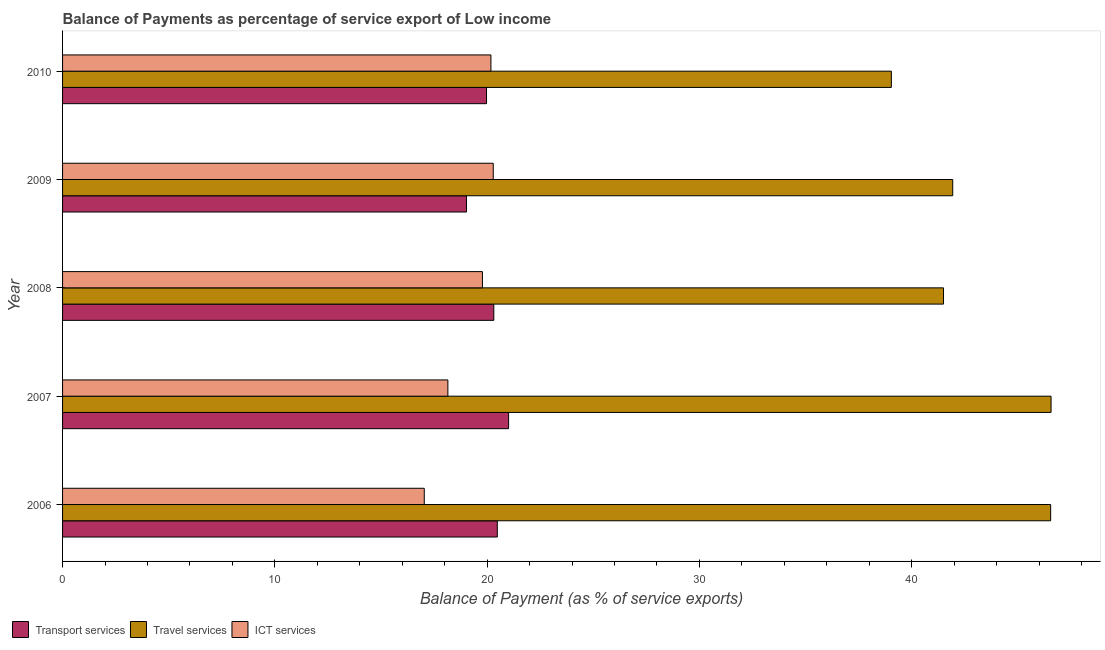How many different coloured bars are there?
Make the answer very short. 3. Are the number of bars per tick equal to the number of legend labels?
Provide a succinct answer. Yes. Are the number of bars on each tick of the Y-axis equal?
Keep it short and to the point. Yes. How many bars are there on the 4th tick from the top?
Your answer should be very brief. 3. In how many cases, is the number of bars for a given year not equal to the number of legend labels?
Make the answer very short. 0. What is the balance of payment of ict services in 2008?
Keep it short and to the point. 19.78. Across all years, what is the maximum balance of payment of ict services?
Provide a succinct answer. 20.29. Across all years, what is the minimum balance of payment of transport services?
Provide a short and direct response. 19.03. In which year was the balance of payment of transport services maximum?
Your response must be concise. 2007. What is the total balance of payment of ict services in the graph?
Make the answer very short. 95.43. What is the difference between the balance of payment of ict services in 2008 and that in 2010?
Provide a succinct answer. -0.4. What is the difference between the balance of payment of ict services in 2010 and the balance of payment of travel services in 2009?
Keep it short and to the point. -21.75. What is the average balance of payment of transport services per year?
Offer a terse response. 20.16. In the year 2006, what is the difference between the balance of payment of transport services and balance of payment of travel services?
Offer a terse response. -26.07. What is the ratio of the balance of payment of transport services in 2007 to that in 2009?
Make the answer very short. 1.1. Is the balance of payment of ict services in 2007 less than that in 2009?
Provide a short and direct response. Yes. Is the difference between the balance of payment of travel services in 2008 and 2009 greater than the difference between the balance of payment of transport services in 2008 and 2009?
Keep it short and to the point. No. What is the difference between the highest and the second highest balance of payment of transport services?
Provide a short and direct response. 0.53. In how many years, is the balance of payment of travel services greater than the average balance of payment of travel services taken over all years?
Keep it short and to the point. 2. Is the sum of the balance of payment of transport services in 2007 and 2008 greater than the maximum balance of payment of ict services across all years?
Provide a succinct answer. Yes. What does the 3rd bar from the top in 2008 represents?
Make the answer very short. Transport services. What does the 1st bar from the bottom in 2008 represents?
Give a very brief answer. Transport services. Is it the case that in every year, the sum of the balance of payment of transport services and balance of payment of travel services is greater than the balance of payment of ict services?
Ensure brevity in your answer.  Yes. How many bars are there?
Give a very brief answer. 15. How many years are there in the graph?
Your response must be concise. 5. What is the difference between two consecutive major ticks on the X-axis?
Your answer should be compact. 10. Does the graph contain any zero values?
Your answer should be compact. No. What is the title of the graph?
Make the answer very short. Balance of Payments as percentage of service export of Low income. Does "Labor Market" appear as one of the legend labels in the graph?
Your answer should be compact. No. What is the label or title of the X-axis?
Give a very brief answer. Balance of Payment (as % of service exports). What is the Balance of Payment (as % of service exports) of Transport services in 2006?
Give a very brief answer. 20.48. What is the Balance of Payment (as % of service exports) of Travel services in 2006?
Provide a succinct answer. 46.54. What is the Balance of Payment (as % of service exports) in ICT services in 2006?
Offer a very short reply. 17.04. What is the Balance of Payment (as % of service exports) in Transport services in 2007?
Provide a succinct answer. 21.01. What is the Balance of Payment (as % of service exports) of Travel services in 2007?
Your answer should be compact. 46.56. What is the Balance of Payment (as % of service exports) of ICT services in 2007?
Your response must be concise. 18.15. What is the Balance of Payment (as % of service exports) of Transport services in 2008?
Your answer should be compact. 20.31. What is the Balance of Payment (as % of service exports) in Travel services in 2008?
Your answer should be compact. 41.5. What is the Balance of Payment (as % of service exports) of ICT services in 2008?
Your answer should be compact. 19.78. What is the Balance of Payment (as % of service exports) of Transport services in 2009?
Offer a very short reply. 19.03. What is the Balance of Payment (as % of service exports) in Travel services in 2009?
Your response must be concise. 41.93. What is the Balance of Payment (as % of service exports) in ICT services in 2009?
Provide a short and direct response. 20.29. What is the Balance of Payment (as % of service exports) of Transport services in 2010?
Your response must be concise. 19.97. What is the Balance of Payment (as % of service exports) of Travel services in 2010?
Your response must be concise. 39.04. What is the Balance of Payment (as % of service exports) in ICT services in 2010?
Provide a succinct answer. 20.18. Across all years, what is the maximum Balance of Payment (as % of service exports) of Transport services?
Ensure brevity in your answer.  21.01. Across all years, what is the maximum Balance of Payment (as % of service exports) in Travel services?
Your answer should be compact. 46.56. Across all years, what is the maximum Balance of Payment (as % of service exports) in ICT services?
Give a very brief answer. 20.29. Across all years, what is the minimum Balance of Payment (as % of service exports) of Transport services?
Keep it short and to the point. 19.03. Across all years, what is the minimum Balance of Payment (as % of service exports) in Travel services?
Give a very brief answer. 39.04. Across all years, what is the minimum Balance of Payment (as % of service exports) in ICT services?
Provide a short and direct response. 17.04. What is the total Balance of Payment (as % of service exports) in Transport services in the graph?
Offer a very short reply. 100.8. What is the total Balance of Payment (as % of service exports) of Travel services in the graph?
Your response must be concise. 215.58. What is the total Balance of Payment (as % of service exports) of ICT services in the graph?
Keep it short and to the point. 95.43. What is the difference between the Balance of Payment (as % of service exports) in Transport services in 2006 and that in 2007?
Your answer should be very brief. -0.53. What is the difference between the Balance of Payment (as % of service exports) of Travel services in 2006 and that in 2007?
Ensure brevity in your answer.  -0.02. What is the difference between the Balance of Payment (as % of service exports) in ICT services in 2006 and that in 2007?
Keep it short and to the point. -1.11. What is the difference between the Balance of Payment (as % of service exports) in Transport services in 2006 and that in 2008?
Keep it short and to the point. 0.16. What is the difference between the Balance of Payment (as % of service exports) of Travel services in 2006 and that in 2008?
Provide a succinct answer. 5.05. What is the difference between the Balance of Payment (as % of service exports) in ICT services in 2006 and that in 2008?
Provide a short and direct response. -2.74. What is the difference between the Balance of Payment (as % of service exports) of Transport services in 2006 and that in 2009?
Provide a succinct answer. 1.45. What is the difference between the Balance of Payment (as % of service exports) of Travel services in 2006 and that in 2009?
Your answer should be very brief. 4.61. What is the difference between the Balance of Payment (as % of service exports) of ICT services in 2006 and that in 2009?
Your response must be concise. -3.25. What is the difference between the Balance of Payment (as % of service exports) in Transport services in 2006 and that in 2010?
Provide a short and direct response. 0.51. What is the difference between the Balance of Payment (as % of service exports) in Travel services in 2006 and that in 2010?
Provide a succinct answer. 7.5. What is the difference between the Balance of Payment (as % of service exports) in ICT services in 2006 and that in 2010?
Ensure brevity in your answer.  -3.14. What is the difference between the Balance of Payment (as % of service exports) of Transport services in 2007 and that in 2008?
Your answer should be compact. 0.7. What is the difference between the Balance of Payment (as % of service exports) of Travel services in 2007 and that in 2008?
Offer a terse response. 5.07. What is the difference between the Balance of Payment (as % of service exports) in ICT services in 2007 and that in 2008?
Your answer should be compact. -1.63. What is the difference between the Balance of Payment (as % of service exports) in Transport services in 2007 and that in 2009?
Offer a very short reply. 1.98. What is the difference between the Balance of Payment (as % of service exports) of Travel services in 2007 and that in 2009?
Your answer should be compact. 4.63. What is the difference between the Balance of Payment (as % of service exports) in ICT services in 2007 and that in 2009?
Your answer should be compact. -2.14. What is the difference between the Balance of Payment (as % of service exports) of Transport services in 2007 and that in 2010?
Provide a short and direct response. 1.04. What is the difference between the Balance of Payment (as % of service exports) in Travel services in 2007 and that in 2010?
Your answer should be compact. 7.52. What is the difference between the Balance of Payment (as % of service exports) of ICT services in 2007 and that in 2010?
Give a very brief answer. -2.03. What is the difference between the Balance of Payment (as % of service exports) of Transport services in 2008 and that in 2009?
Your response must be concise. 1.29. What is the difference between the Balance of Payment (as % of service exports) in Travel services in 2008 and that in 2009?
Offer a terse response. -0.43. What is the difference between the Balance of Payment (as % of service exports) of ICT services in 2008 and that in 2009?
Provide a succinct answer. -0.51. What is the difference between the Balance of Payment (as % of service exports) in Transport services in 2008 and that in 2010?
Provide a short and direct response. 0.34. What is the difference between the Balance of Payment (as % of service exports) of Travel services in 2008 and that in 2010?
Provide a succinct answer. 2.46. What is the difference between the Balance of Payment (as % of service exports) of ICT services in 2008 and that in 2010?
Make the answer very short. -0.4. What is the difference between the Balance of Payment (as % of service exports) of Transport services in 2009 and that in 2010?
Offer a very short reply. -0.94. What is the difference between the Balance of Payment (as % of service exports) of Travel services in 2009 and that in 2010?
Your response must be concise. 2.89. What is the difference between the Balance of Payment (as % of service exports) in ICT services in 2009 and that in 2010?
Keep it short and to the point. 0.11. What is the difference between the Balance of Payment (as % of service exports) of Transport services in 2006 and the Balance of Payment (as % of service exports) of Travel services in 2007?
Make the answer very short. -26.09. What is the difference between the Balance of Payment (as % of service exports) in Transport services in 2006 and the Balance of Payment (as % of service exports) in ICT services in 2007?
Your answer should be compact. 2.33. What is the difference between the Balance of Payment (as % of service exports) in Travel services in 2006 and the Balance of Payment (as % of service exports) in ICT services in 2007?
Your response must be concise. 28.39. What is the difference between the Balance of Payment (as % of service exports) in Transport services in 2006 and the Balance of Payment (as % of service exports) in Travel services in 2008?
Give a very brief answer. -21.02. What is the difference between the Balance of Payment (as % of service exports) in Transport services in 2006 and the Balance of Payment (as % of service exports) in ICT services in 2008?
Provide a succinct answer. 0.7. What is the difference between the Balance of Payment (as % of service exports) of Travel services in 2006 and the Balance of Payment (as % of service exports) of ICT services in 2008?
Your response must be concise. 26.77. What is the difference between the Balance of Payment (as % of service exports) in Transport services in 2006 and the Balance of Payment (as % of service exports) in Travel services in 2009?
Make the answer very short. -21.45. What is the difference between the Balance of Payment (as % of service exports) in Transport services in 2006 and the Balance of Payment (as % of service exports) in ICT services in 2009?
Keep it short and to the point. 0.19. What is the difference between the Balance of Payment (as % of service exports) in Travel services in 2006 and the Balance of Payment (as % of service exports) in ICT services in 2009?
Offer a very short reply. 26.26. What is the difference between the Balance of Payment (as % of service exports) in Transport services in 2006 and the Balance of Payment (as % of service exports) in Travel services in 2010?
Provide a short and direct response. -18.56. What is the difference between the Balance of Payment (as % of service exports) in Transport services in 2006 and the Balance of Payment (as % of service exports) in ICT services in 2010?
Your answer should be very brief. 0.3. What is the difference between the Balance of Payment (as % of service exports) of Travel services in 2006 and the Balance of Payment (as % of service exports) of ICT services in 2010?
Your answer should be very brief. 26.37. What is the difference between the Balance of Payment (as % of service exports) of Transport services in 2007 and the Balance of Payment (as % of service exports) of Travel services in 2008?
Make the answer very short. -20.49. What is the difference between the Balance of Payment (as % of service exports) of Transport services in 2007 and the Balance of Payment (as % of service exports) of ICT services in 2008?
Your response must be concise. 1.23. What is the difference between the Balance of Payment (as % of service exports) in Travel services in 2007 and the Balance of Payment (as % of service exports) in ICT services in 2008?
Keep it short and to the point. 26.79. What is the difference between the Balance of Payment (as % of service exports) of Transport services in 2007 and the Balance of Payment (as % of service exports) of Travel services in 2009?
Ensure brevity in your answer.  -20.92. What is the difference between the Balance of Payment (as % of service exports) in Transport services in 2007 and the Balance of Payment (as % of service exports) in ICT services in 2009?
Your response must be concise. 0.72. What is the difference between the Balance of Payment (as % of service exports) in Travel services in 2007 and the Balance of Payment (as % of service exports) in ICT services in 2009?
Your answer should be compact. 26.28. What is the difference between the Balance of Payment (as % of service exports) of Transport services in 2007 and the Balance of Payment (as % of service exports) of Travel services in 2010?
Provide a short and direct response. -18.03. What is the difference between the Balance of Payment (as % of service exports) of Transport services in 2007 and the Balance of Payment (as % of service exports) of ICT services in 2010?
Provide a short and direct response. 0.83. What is the difference between the Balance of Payment (as % of service exports) in Travel services in 2007 and the Balance of Payment (as % of service exports) in ICT services in 2010?
Offer a very short reply. 26.39. What is the difference between the Balance of Payment (as % of service exports) in Transport services in 2008 and the Balance of Payment (as % of service exports) in Travel services in 2009?
Provide a succinct answer. -21.62. What is the difference between the Balance of Payment (as % of service exports) in Transport services in 2008 and the Balance of Payment (as % of service exports) in ICT services in 2009?
Give a very brief answer. 0.03. What is the difference between the Balance of Payment (as % of service exports) in Travel services in 2008 and the Balance of Payment (as % of service exports) in ICT services in 2009?
Offer a terse response. 21.21. What is the difference between the Balance of Payment (as % of service exports) in Transport services in 2008 and the Balance of Payment (as % of service exports) in Travel services in 2010?
Give a very brief answer. -18.73. What is the difference between the Balance of Payment (as % of service exports) of Transport services in 2008 and the Balance of Payment (as % of service exports) of ICT services in 2010?
Your answer should be compact. 0.14. What is the difference between the Balance of Payment (as % of service exports) of Travel services in 2008 and the Balance of Payment (as % of service exports) of ICT services in 2010?
Provide a succinct answer. 21.32. What is the difference between the Balance of Payment (as % of service exports) in Transport services in 2009 and the Balance of Payment (as % of service exports) in Travel services in 2010?
Your response must be concise. -20.01. What is the difference between the Balance of Payment (as % of service exports) in Transport services in 2009 and the Balance of Payment (as % of service exports) in ICT services in 2010?
Your answer should be very brief. -1.15. What is the difference between the Balance of Payment (as % of service exports) in Travel services in 2009 and the Balance of Payment (as % of service exports) in ICT services in 2010?
Provide a succinct answer. 21.75. What is the average Balance of Payment (as % of service exports) of Transport services per year?
Keep it short and to the point. 20.16. What is the average Balance of Payment (as % of service exports) in Travel services per year?
Make the answer very short. 43.12. What is the average Balance of Payment (as % of service exports) in ICT services per year?
Ensure brevity in your answer.  19.09. In the year 2006, what is the difference between the Balance of Payment (as % of service exports) in Transport services and Balance of Payment (as % of service exports) in Travel services?
Make the answer very short. -26.07. In the year 2006, what is the difference between the Balance of Payment (as % of service exports) of Transport services and Balance of Payment (as % of service exports) of ICT services?
Provide a succinct answer. 3.44. In the year 2006, what is the difference between the Balance of Payment (as % of service exports) of Travel services and Balance of Payment (as % of service exports) of ICT services?
Make the answer very short. 29.51. In the year 2007, what is the difference between the Balance of Payment (as % of service exports) of Transport services and Balance of Payment (as % of service exports) of Travel services?
Offer a very short reply. -25.55. In the year 2007, what is the difference between the Balance of Payment (as % of service exports) of Transport services and Balance of Payment (as % of service exports) of ICT services?
Provide a succinct answer. 2.86. In the year 2007, what is the difference between the Balance of Payment (as % of service exports) in Travel services and Balance of Payment (as % of service exports) in ICT services?
Provide a succinct answer. 28.41. In the year 2008, what is the difference between the Balance of Payment (as % of service exports) in Transport services and Balance of Payment (as % of service exports) in Travel services?
Your answer should be very brief. -21.18. In the year 2008, what is the difference between the Balance of Payment (as % of service exports) in Transport services and Balance of Payment (as % of service exports) in ICT services?
Give a very brief answer. 0.53. In the year 2008, what is the difference between the Balance of Payment (as % of service exports) in Travel services and Balance of Payment (as % of service exports) in ICT services?
Your answer should be compact. 21.72. In the year 2009, what is the difference between the Balance of Payment (as % of service exports) of Transport services and Balance of Payment (as % of service exports) of Travel services?
Offer a very short reply. -22.9. In the year 2009, what is the difference between the Balance of Payment (as % of service exports) of Transport services and Balance of Payment (as % of service exports) of ICT services?
Give a very brief answer. -1.26. In the year 2009, what is the difference between the Balance of Payment (as % of service exports) of Travel services and Balance of Payment (as % of service exports) of ICT services?
Keep it short and to the point. 21.64. In the year 2010, what is the difference between the Balance of Payment (as % of service exports) in Transport services and Balance of Payment (as % of service exports) in Travel services?
Your answer should be very brief. -19.07. In the year 2010, what is the difference between the Balance of Payment (as % of service exports) in Transport services and Balance of Payment (as % of service exports) in ICT services?
Give a very brief answer. -0.21. In the year 2010, what is the difference between the Balance of Payment (as % of service exports) of Travel services and Balance of Payment (as % of service exports) of ICT services?
Ensure brevity in your answer.  18.86. What is the ratio of the Balance of Payment (as % of service exports) of Transport services in 2006 to that in 2007?
Give a very brief answer. 0.97. What is the ratio of the Balance of Payment (as % of service exports) of Travel services in 2006 to that in 2007?
Your answer should be very brief. 1. What is the ratio of the Balance of Payment (as % of service exports) in ICT services in 2006 to that in 2007?
Give a very brief answer. 0.94. What is the ratio of the Balance of Payment (as % of service exports) in Travel services in 2006 to that in 2008?
Offer a very short reply. 1.12. What is the ratio of the Balance of Payment (as % of service exports) in ICT services in 2006 to that in 2008?
Your answer should be very brief. 0.86. What is the ratio of the Balance of Payment (as % of service exports) of Transport services in 2006 to that in 2009?
Provide a succinct answer. 1.08. What is the ratio of the Balance of Payment (as % of service exports) of Travel services in 2006 to that in 2009?
Make the answer very short. 1.11. What is the ratio of the Balance of Payment (as % of service exports) of ICT services in 2006 to that in 2009?
Your response must be concise. 0.84. What is the ratio of the Balance of Payment (as % of service exports) in Transport services in 2006 to that in 2010?
Your answer should be compact. 1.03. What is the ratio of the Balance of Payment (as % of service exports) in Travel services in 2006 to that in 2010?
Your response must be concise. 1.19. What is the ratio of the Balance of Payment (as % of service exports) of ICT services in 2006 to that in 2010?
Make the answer very short. 0.84. What is the ratio of the Balance of Payment (as % of service exports) of Transport services in 2007 to that in 2008?
Give a very brief answer. 1.03. What is the ratio of the Balance of Payment (as % of service exports) of Travel services in 2007 to that in 2008?
Ensure brevity in your answer.  1.12. What is the ratio of the Balance of Payment (as % of service exports) in ICT services in 2007 to that in 2008?
Offer a very short reply. 0.92. What is the ratio of the Balance of Payment (as % of service exports) of Transport services in 2007 to that in 2009?
Provide a short and direct response. 1.1. What is the ratio of the Balance of Payment (as % of service exports) of Travel services in 2007 to that in 2009?
Your answer should be compact. 1.11. What is the ratio of the Balance of Payment (as % of service exports) in ICT services in 2007 to that in 2009?
Provide a succinct answer. 0.89. What is the ratio of the Balance of Payment (as % of service exports) of Transport services in 2007 to that in 2010?
Make the answer very short. 1.05. What is the ratio of the Balance of Payment (as % of service exports) of Travel services in 2007 to that in 2010?
Provide a short and direct response. 1.19. What is the ratio of the Balance of Payment (as % of service exports) of ICT services in 2007 to that in 2010?
Provide a succinct answer. 0.9. What is the ratio of the Balance of Payment (as % of service exports) in Transport services in 2008 to that in 2009?
Your answer should be compact. 1.07. What is the ratio of the Balance of Payment (as % of service exports) in Travel services in 2008 to that in 2009?
Give a very brief answer. 0.99. What is the ratio of the Balance of Payment (as % of service exports) of ICT services in 2008 to that in 2009?
Provide a succinct answer. 0.97. What is the ratio of the Balance of Payment (as % of service exports) in Transport services in 2008 to that in 2010?
Your response must be concise. 1.02. What is the ratio of the Balance of Payment (as % of service exports) in Travel services in 2008 to that in 2010?
Give a very brief answer. 1.06. What is the ratio of the Balance of Payment (as % of service exports) of ICT services in 2008 to that in 2010?
Ensure brevity in your answer.  0.98. What is the ratio of the Balance of Payment (as % of service exports) of Transport services in 2009 to that in 2010?
Keep it short and to the point. 0.95. What is the ratio of the Balance of Payment (as % of service exports) in Travel services in 2009 to that in 2010?
Your answer should be very brief. 1.07. What is the ratio of the Balance of Payment (as % of service exports) in ICT services in 2009 to that in 2010?
Give a very brief answer. 1.01. What is the difference between the highest and the second highest Balance of Payment (as % of service exports) of Transport services?
Offer a terse response. 0.53. What is the difference between the highest and the second highest Balance of Payment (as % of service exports) of Travel services?
Give a very brief answer. 0.02. What is the difference between the highest and the second highest Balance of Payment (as % of service exports) in ICT services?
Provide a succinct answer. 0.11. What is the difference between the highest and the lowest Balance of Payment (as % of service exports) in Transport services?
Ensure brevity in your answer.  1.98. What is the difference between the highest and the lowest Balance of Payment (as % of service exports) in Travel services?
Offer a very short reply. 7.52. What is the difference between the highest and the lowest Balance of Payment (as % of service exports) of ICT services?
Offer a very short reply. 3.25. 